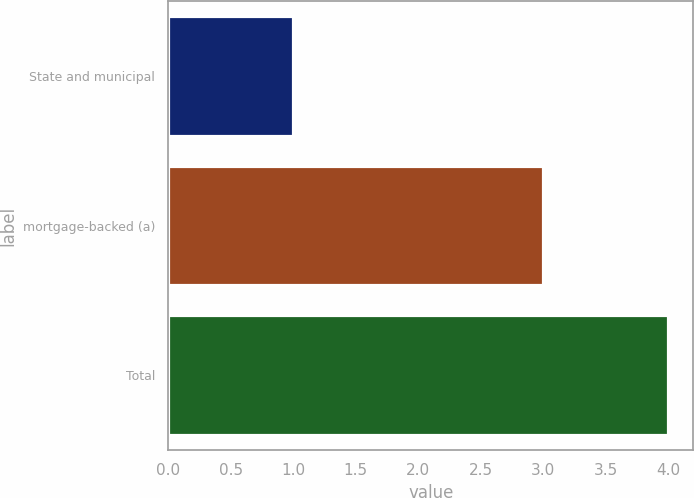Convert chart to OTSL. <chart><loc_0><loc_0><loc_500><loc_500><bar_chart><fcel>State and municipal<fcel>mortgage-backed (a)<fcel>Total<nl><fcel>1<fcel>3<fcel>4<nl></chart> 